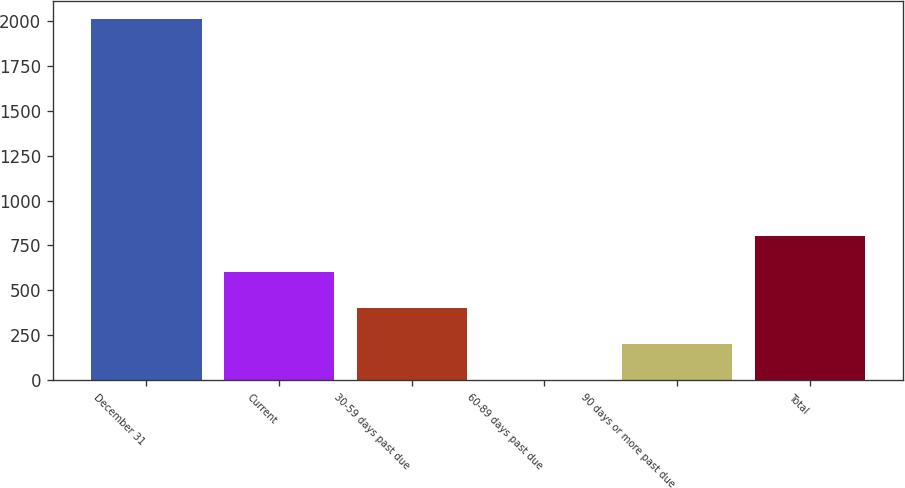Convert chart. <chart><loc_0><loc_0><loc_500><loc_500><bar_chart><fcel>December 31<fcel>Current<fcel>30-59 days past due<fcel>60-89 days past due<fcel>90 days or more past due<fcel>Total<nl><fcel>2012<fcel>604.09<fcel>402.96<fcel>0.7<fcel>201.83<fcel>805.22<nl></chart> 